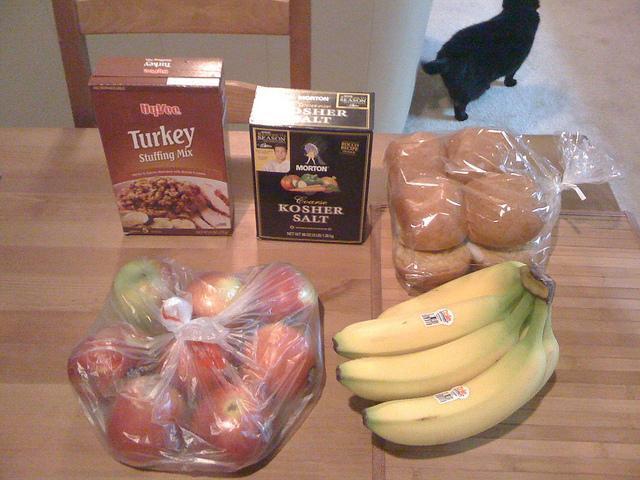Evaluate: Does the caption "The apple is at the left side of the banana." match the image?
Answer yes or no. Yes. 